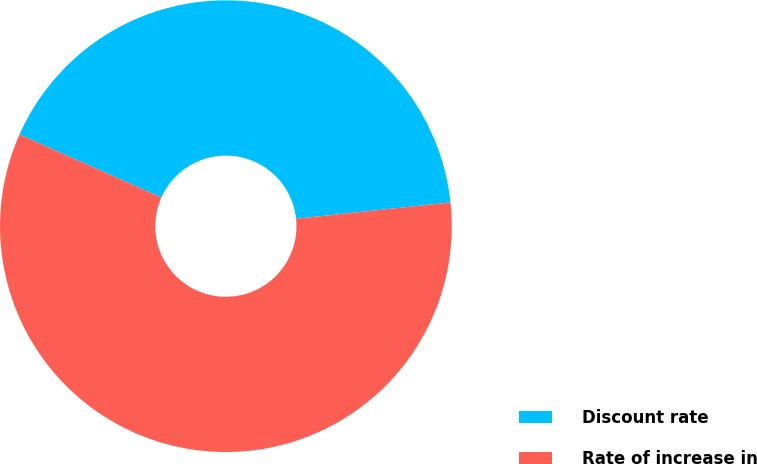Convert chart to OTSL. <chart><loc_0><loc_0><loc_500><loc_500><pie_chart><fcel>Discount rate<fcel>Rate of increase in<nl><fcel>41.67%<fcel>58.33%<nl></chart> 